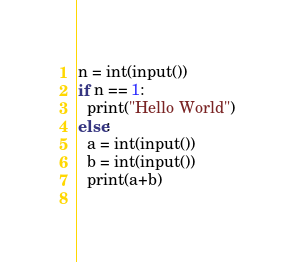<code> <loc_0><loc_0><loc_500><loc_500><_Python_>n = int(input())
if n == 1:
  print("Hello World")
else:
  a = int(input())
  b = int(input())
  print(a+b)
  
</code> 